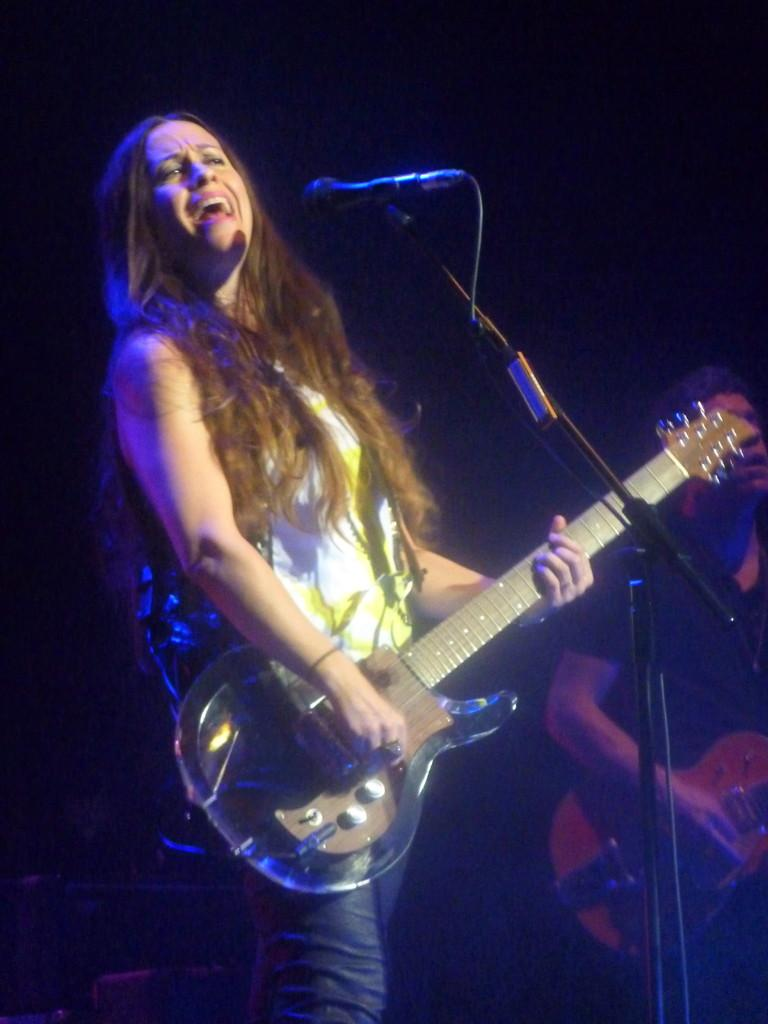What is the lady in the image doing? The lady in the image is playing a guitar. What object is in front of the lady? There is a microphone in front of the lady. What is the guy in the background of the image doing? The guy in the background of the image is playing a guitar. How many chairs are visible in the image? There is no mention of chairs in the provided facts, so we cannot determine the number of chairs in the image. 